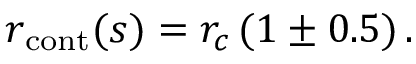Convert formula to latex. <formula><loc_0><loc_0><loc_500><loc_500>r _ { c o n t } ( s ) = r _ { c } \, ( 1 \pm 0 . 5 ) \, .</formula> 